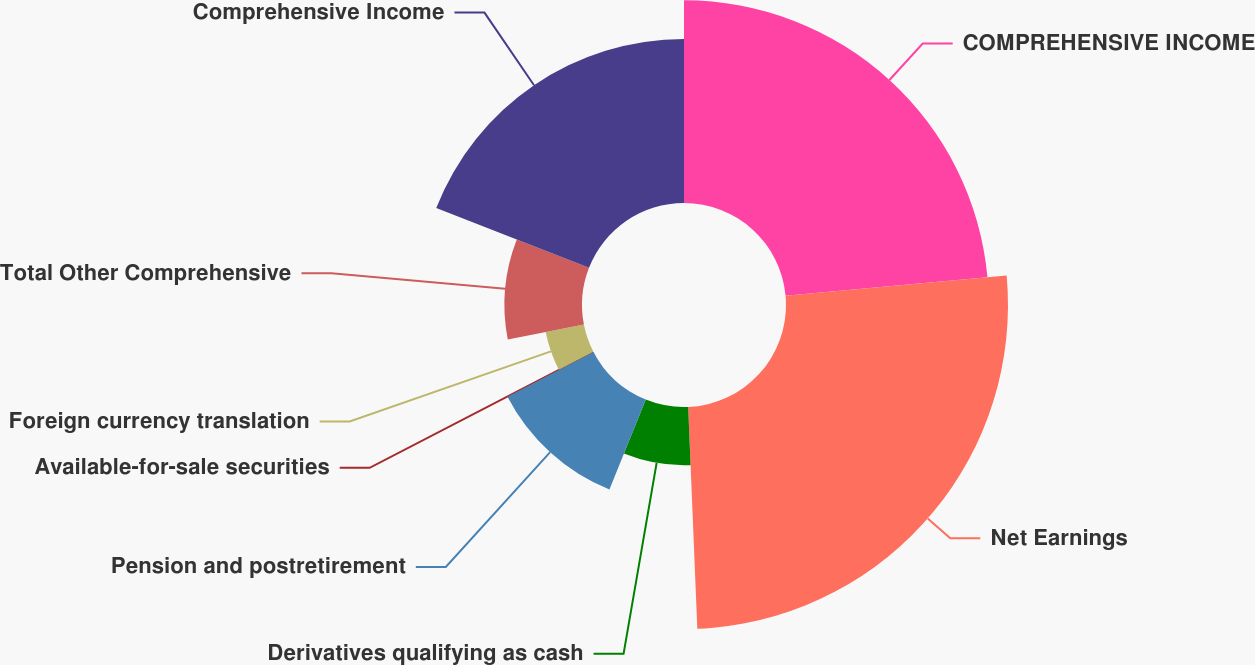Convert chart. <chart><loc_0><loc_0><loc_500><loc_500><pie_chart><fcel>COMPREHENSIVE INCOME<fcel>Net Earnings<fcel>Derivatives qualifying as cash<fcel>Pension and postretirement<fcel>Available-for-sale securities<fcel>Foreign currency translation<fcel>Total Other Comprehensive<fcel>Comprehensive Income<nl><fcel>23.55%<fcel>25.79%<fcel>6.77%<fcel>11.26%<fcel>0.03%<fcel>4.52%<fcel>9.01%<fcel>19.06%<nl></chart> 